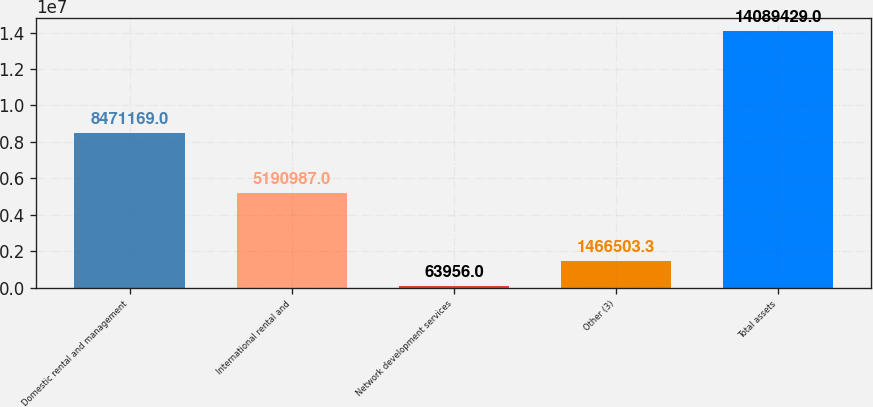Convert chart to OTSL. <chart><loc_0><loc_0><loc_500><loc_500><bar_chart><fcel>Domestic rental and management<fcel>International rental and<fcel>Network development services<fcel>Other (3)<fcel>Total assets<nl><fcel>8.47117e+06<fcel>5.19099e+06<fcel>63956<fcel>1.4665e+06<fcel>1.40894e+07<nl></chart> 